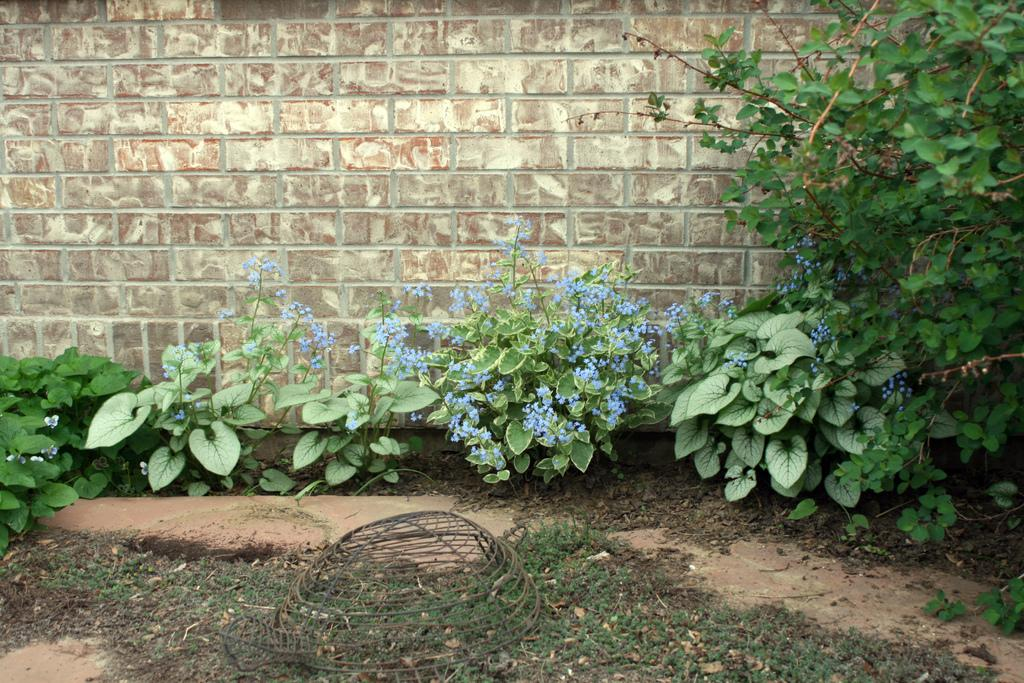What type of vegetation can be seen in the image? There is grass in the image. What else can be seen in the backdrop of the image? There are plants with blue color flowers and a brick wall in the backdrop of the image. What channel is the coal being transported on in the image? There is no coal or channel present in the image. 